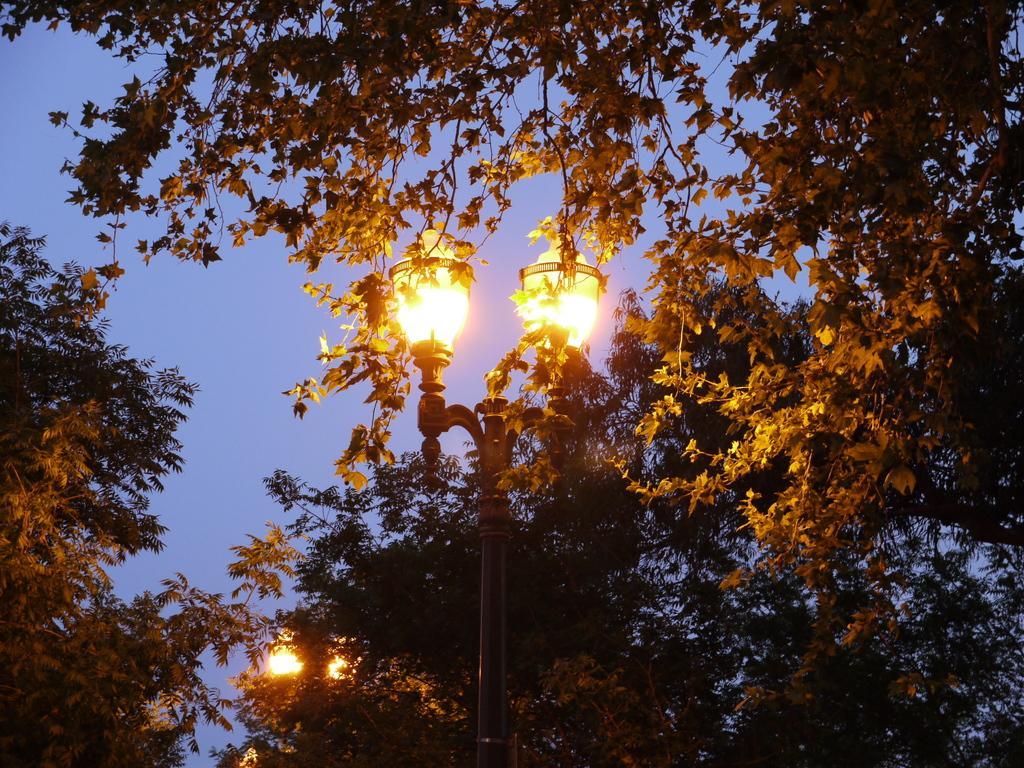Describe this image in one or two sentences. In this image I can see few trees which are green and yellow in color, a pole and two lights to the top of the pole. In the background I can see the sky. 